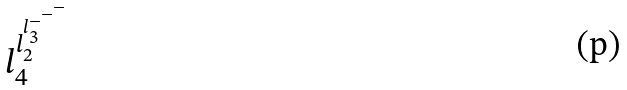Convert formula to latex. <formula><loc_0><loc_0><loc_500><loc_500>l _ { 4 } ^ { l _ { 2 } ^ { l _ { 3 } ^ { - ^ { - ^ { - } } } } }</formula> 